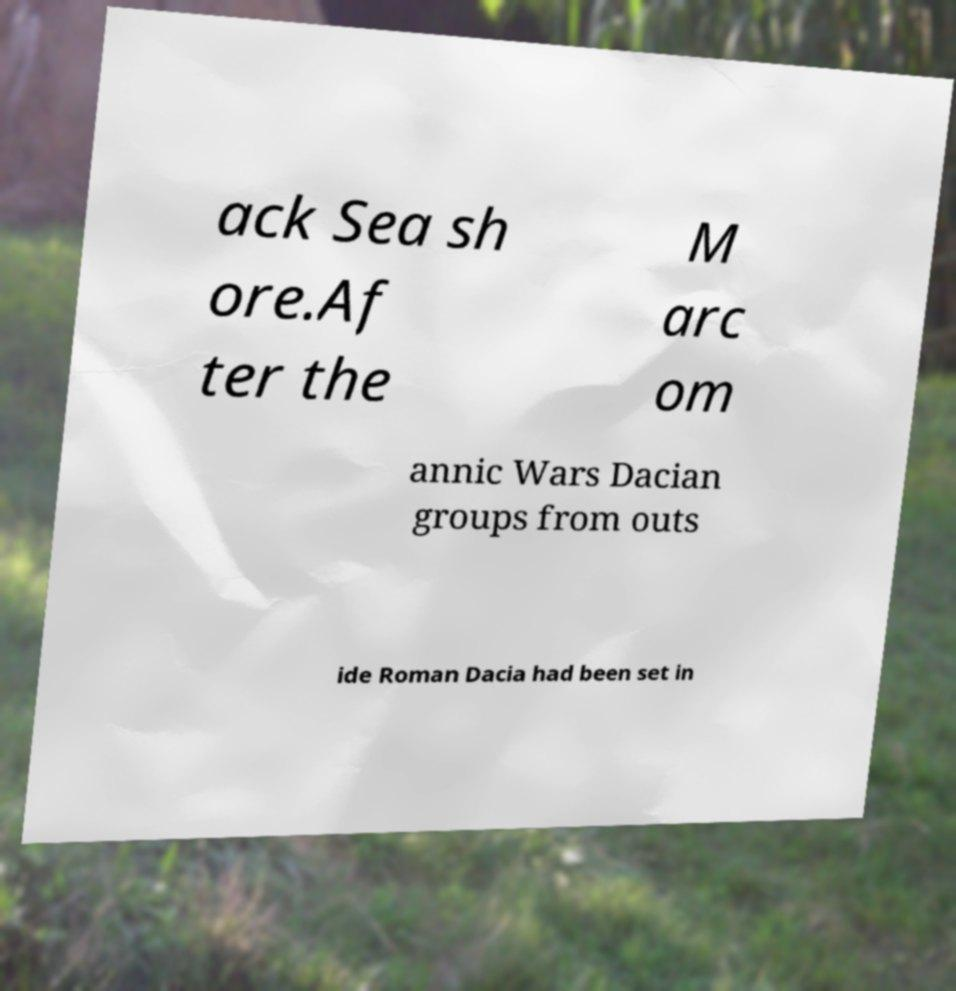Can you read and provide the text displayed in the image?This photo seems to have some interesting text. Can you extract and type it out for me? ack Sea sh ore.Af ter the M arc om annic Wars Dacian groups from outs ide Roman Dacia had been set in 